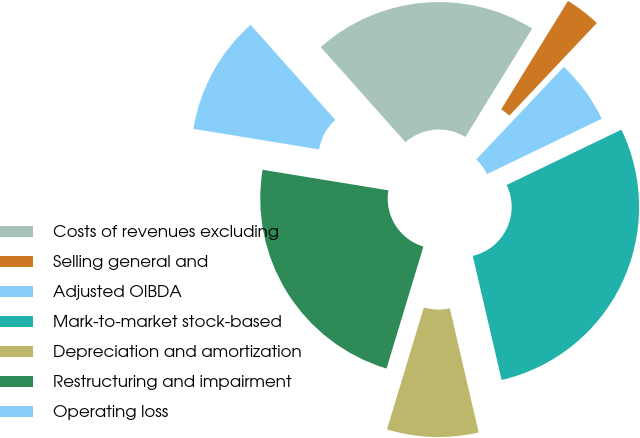<chart> <loc_0><loc_0><loc_500><loc_500><pie_chart><fcel>Costs of revenues excluding<fcel>Selling general and<fcel>Adjusted OIBDA<fcel>Mark-to-market stock-based<fcel>Depreciation and amortization<fcel>Restructuring and impairment<fcel>Operating loss<nl><fcel>20.37%<fcel>3.26%<fcel>5.79%<fcel>28.52%<fcel>8.31%<fcel>22.9%<fcel>10.84%<nl></chart> 